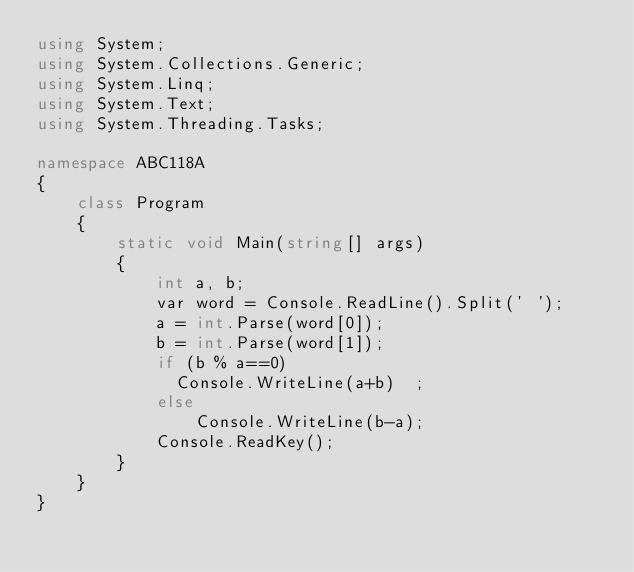Convert code to text. <code><loc_0><loc_0><loc_500><loc_500><_C#_>using System;
using System.Collections.Generic;
using System.Linq;
using System.Text;
using System.Threading.Tasks;

namespace ABC118A
{
    class Program
    {
        static void Main(string[] args)
        {
            int a, b;
            var word = Console.ReadLine().Split(' ');
            a = int.Parse(word[0]);
            b = int.Parse(word[1]);
            if (b % a==0)
              Console.WriteLine(a+b)  ;
            else
                Console.WriteLine(b-a);
            Console.ReadKey();
        }
    }
}
</code> 